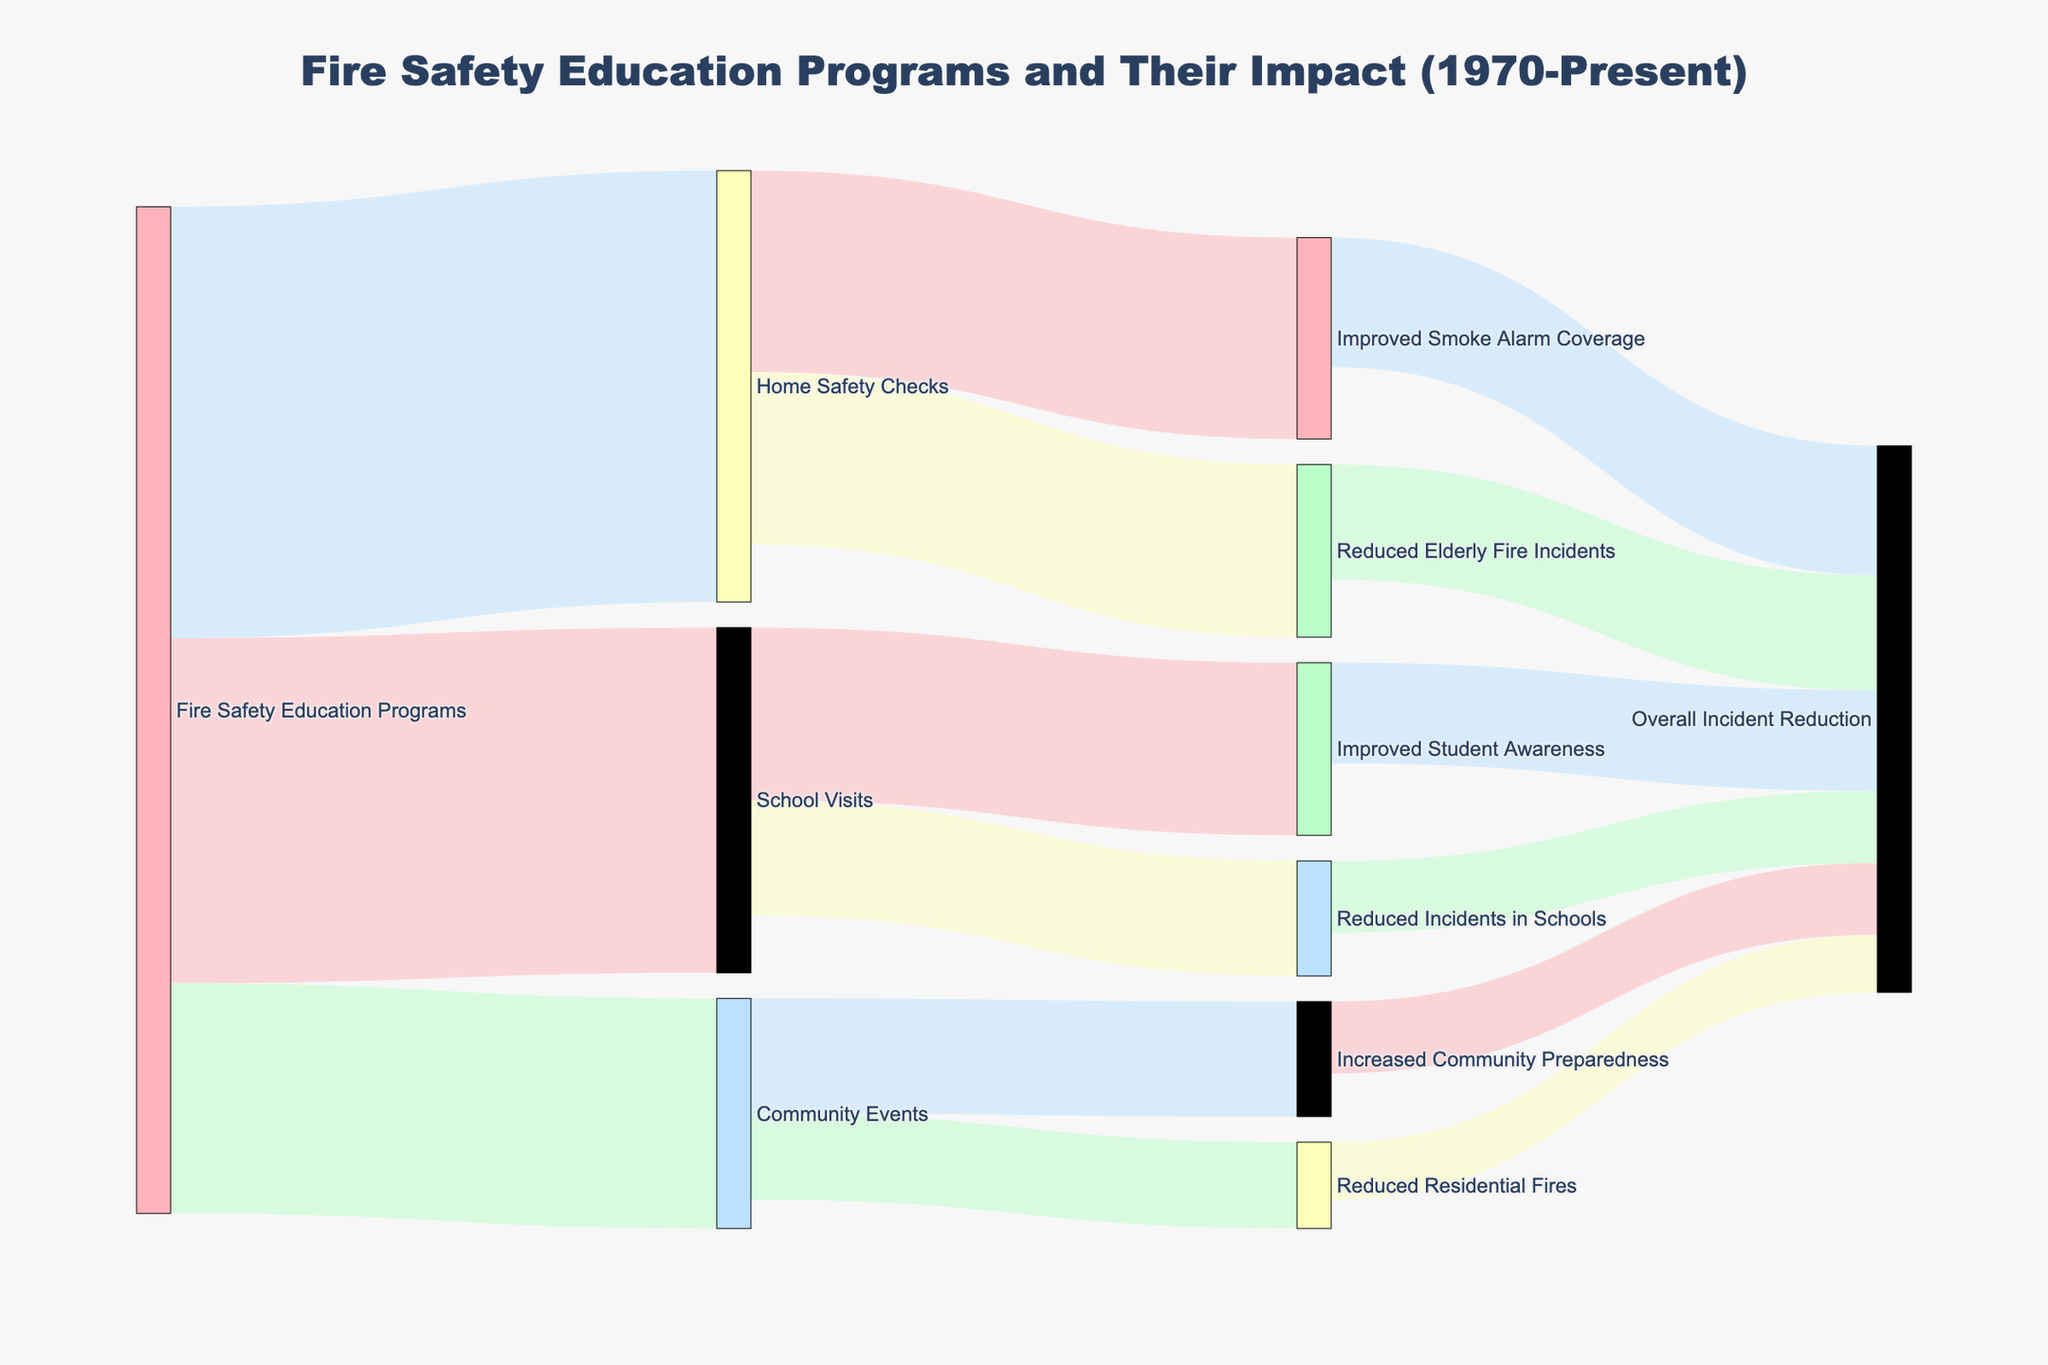What are the main types of fire safety education programs shown in the diagram? The Sankey diagram breaks down the Fire Safety Education Programs into three main categories: School Visits, Community Events, and Home Safety Checks.
Answer: School Visits, Community Events, Home Safety Checks How many incidents were reduced in schools as a result of school visits? According to the figure, School Visits resulted in 400 decreased incidents in schools.
Answer: 400 What is the total number of programs implemented for Home Safety Checks? For Home Safety Checks, there were 1500 programs implemented. This is directly visible in the Sankey diagram where the total value from Fire Safety Education Programs to Home Safety Checks is 1500.
Answer: 1500 How many community events led to increased community preparedness? The diagram shows that 800 Community Events were organized, and 400 of those led to Increased Community Preparedness.
Answer: 400 Which type of fire safety program contributed most to reducing overall incidents? Summing up all the contributions towards "Overall Incident Reduction" from various nodes: School Visits (250 from Reduced Incidents in Schools and 350 from Improved Student Awareness), Community Events (200 from Reduced Residential Fires and 250 from Increased Community Preparedness), and Home Safety Checks (400 from Reduced Elderly Fire Incidents and 450 from Improved Smoke Alarm Coverage). Home Safety Checks contribute most with 850 incidents reduced overall.
Answer: Home Safety Checks What are the results of improved smoke alarm coverage from home safety checks? Improved Smoke Alarm Coverage from Home Safety Checks results in 700 and contributes to reducing Overall Incident Reduction by 450.
Answer: 700, 450 Which has a larger impact on overall incident reduction: school visits or community events? School Visits result in a total of 600 (250 from Reduced Incidents in Schools and 350 from Improved Student Awareness) towards overall incident reduction. Community Events sum up to 450 (200 from Reduced Residential Fires and 250 from Increased Community Preparedness). School Visits have a larger impact.
Answer: School Visits Compare the impact on overall incident reduction between the categories Improved Student Awareness and Increased Community Preparedness. Improved Student Awareness contributes 350 towards Overall Incident Reduction, while Increased Community Preparedness contributes 250. Therefore, Improved Student Awareness has a larger impact.
Answer: Improved Student Awareness How do the School Visits compare to the Home Safety Checks in terms of reducing individual incident types? School Visits lead to 400 Reduced Incidents in Schools and 600 Improved Student Awareness, whereas Home Safety Checks lead to 600 Reduced Elderly Fire Incidents and 700 Improved Smoke Alarm Coverage. Home Safety Checks address higher individual incident types.
Answer: Home Safety Checks 